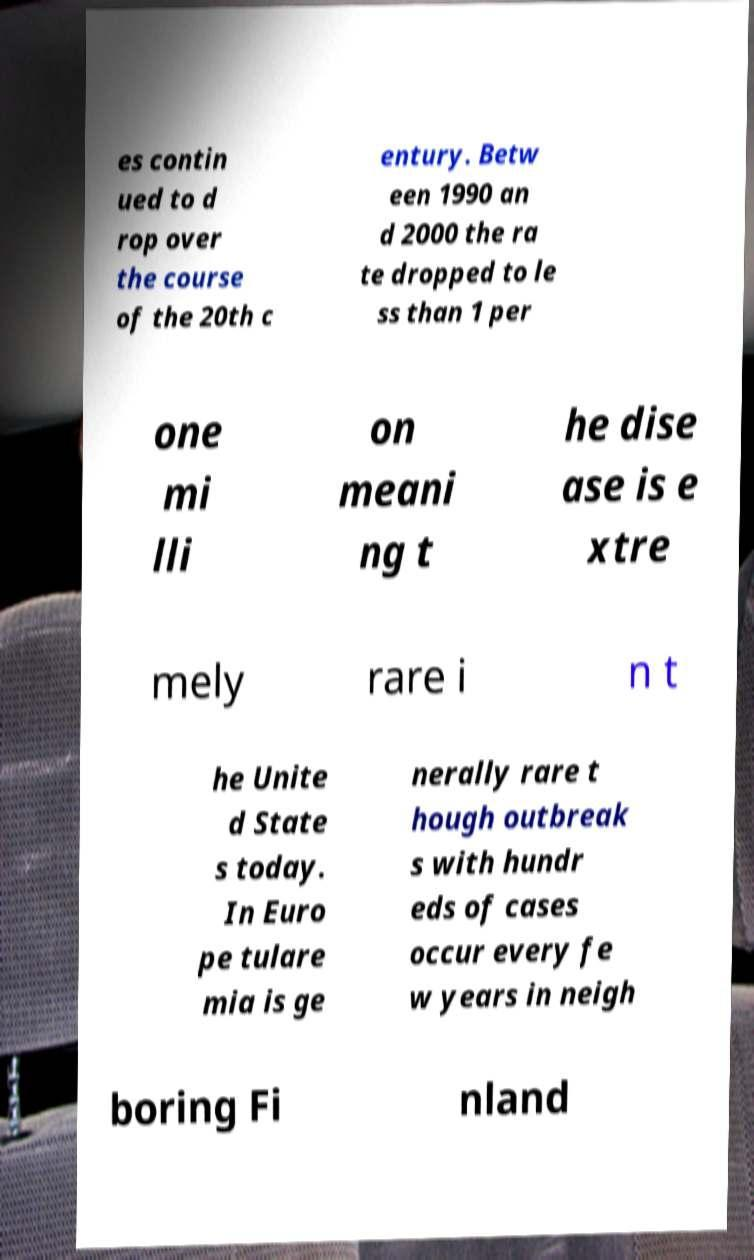What messages or text are displayed in this image? I need them in a readable, typed format. es contin ued to d rop over the course of the 20th c entury. Betw een 1990 an d 2000 the ra te dropped to le ss than 1 per one mi lli on meani ng t he dise ase is e xtre mely rare i n t he Unite d State s today. In Euro pe tulare mia is ge nerally rare t hough outbreak s with hundr eds of cases occur every fe w years in neigh boring Fi nland 